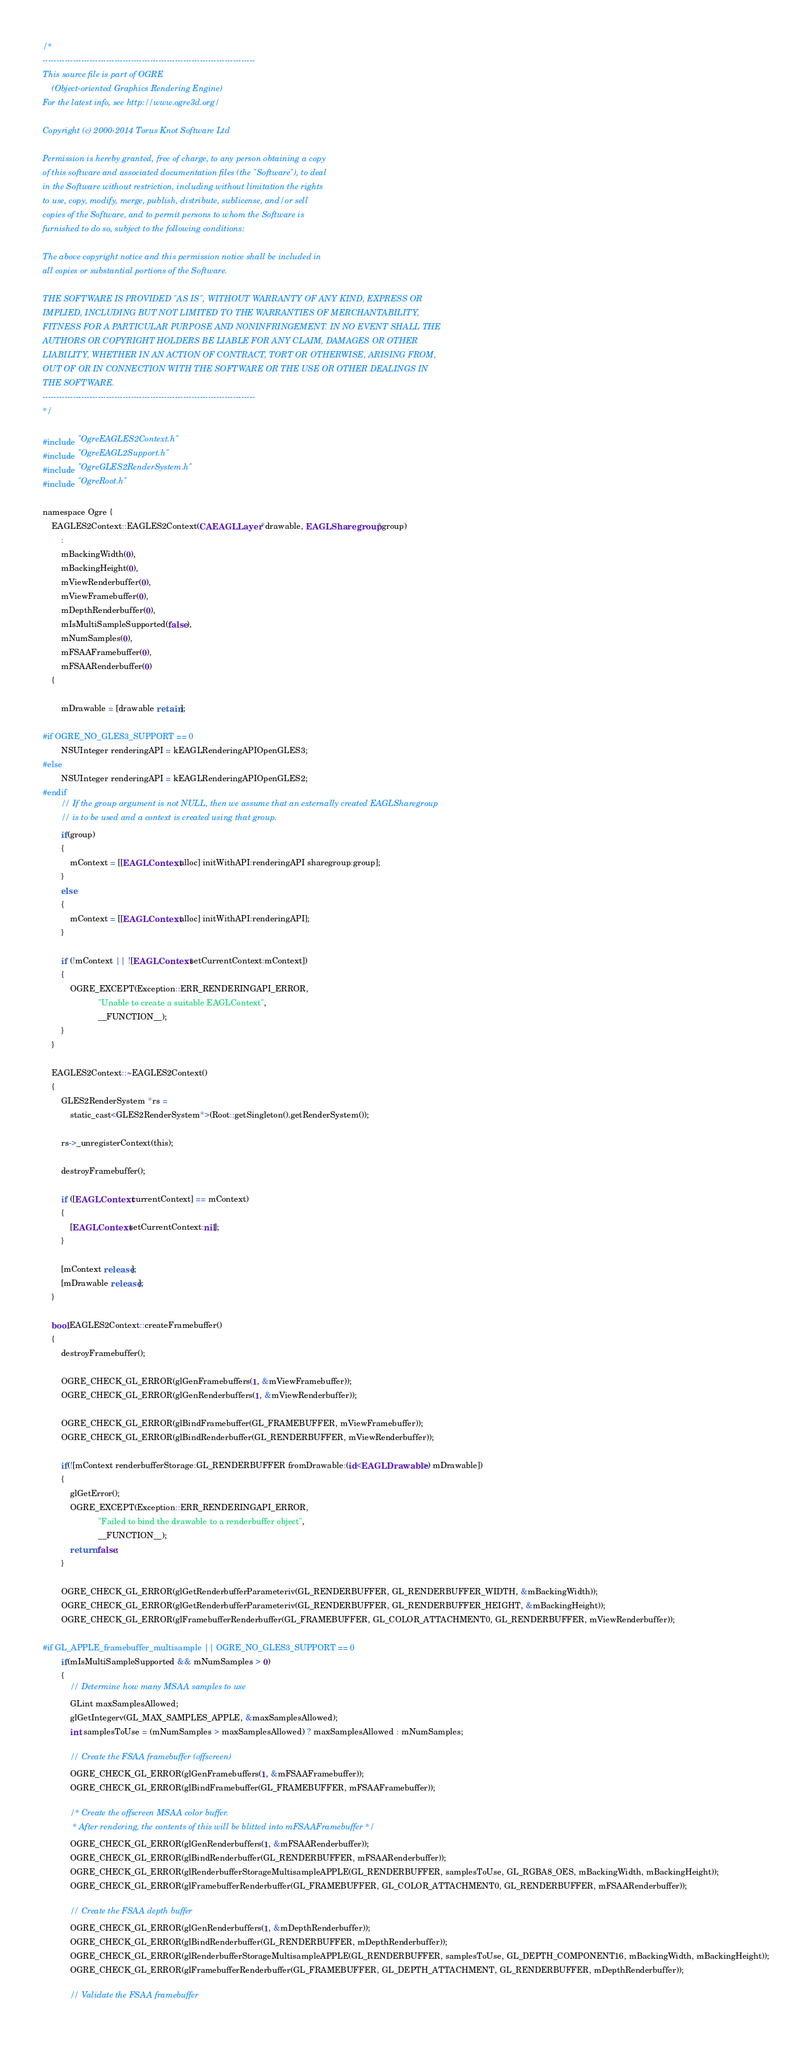<code> <loc_0><loc_0><loc_500><loc_500><_ObjectiveC_>/*
-----------------------------------------------------------------------------
This source file is part of OGRE
    (Object-oriented Graphics Rendering Engine)
For the latest info, see http://www.ogre3d.org/

Copyright (c) 2000-2014 Torus Knot Software Ltd

Permission is hereby granted, free of charge, to any person obtaining a copy
of this software and associated documentation files (the "Software"), to deal
in the Software without restriction, including without limitation the rights
to use, copy, modify, merge, publish, distribute, sublicense, and/or sell
copies of the Software, and to permit persons to whom the Software is
furnished to do so, subject to the following conditions:

The above copyright notice and this permission notice shall be included in
all copies or substantial portions of the Software.

THE SOFTWARE IS PROVIDED "AS IS", WITHOUT WARRANTY OF ANY KIND, EXPRESS OR
IMPLIED, INCLUDING BUT NOT LIMITED TO THE WARRANTIES OF MERCHANTABILITY,
FITNESS FOR A PARTICULAR PURPOSE AND NONINFRINGEMENT. IN NO EVENT SHALL THE
AUTHORS OR COPYRIGHT HOLDERS BE LIABLE FOR ANY CLAIM, DAMAGES OR OTHER
LIABILITY, WHETHER IN AN ACTION OF CONTRACT, TORT OR OTHERWISE, ARISING FROM,
OUT OF OR IN CONNECTION WITH THE SOFTWARE OR THE USE OR OTHER DEALINGS IN
THE SOFTWARE.
-----------------------------------------------------------------------------
*/

#include "OgreEAGLES2Context.h"
#include "OgreEAGL2Support.h"
#include "OgreGLES2RenderSystem.h"
#include "OgreRoot.h"

namespace Ogre {
    EAGLES2Context::EAGLES2Context(CAEAGLLayer *drawable, EAGLSharegroup *group)
        : 
        mBackingWidth(0),
        mBackingHeight(0),
        mViewRenderbuffer(0),
        mViewFramebuffer(0),
        mDepthRenderbuffer(0),
        mIsMultiSampleSupported(false),
        mNumSamples(0),
        mFSAAFramebuffer(0),
        mFSAARenderbuffer(0)
    {

        mDrawable = [drawable retain];

#if OGRE_NO_GLES3_SUPPORT == 0
        NSUInteger renderingAPI = kEAGLRenderingAPIOpenGLES3;
#else
        NSUInteger renderingAPI = kEAGLRenderingAPIOpenGLES2;
#endif
        // If the group argument is not NULL, then we assume that an externally created EAGLSharegroup
        // is to be used and a context is created using that group.
        if(group)
        {
            mContext = [[EAGLContext alloc] initWithAPI:renderingAPI sharegroup:group];
        }
        else
        {
            mContext = [[EAGLContext alloc] initWithAPI:renderingAPI];
        }

        if (!mContext || ![EAGLContext setCurrentContext:mContext])
        {
            OGRE_EXCEPT(Exception::ERR_RENDERINGAPI_ERROR,
                        "Unable to create a suitable EAGLContext",
                        __FUNCTION__);
        }
    }

    EAGLES2Context::~EAGLES2Context()
    {
        GLES2RenderSystem *rs =
            static_cast<GLES2RenderSystem*>(Root::getSingleton().getRenderSystem());

        rs->_unregisterContext(this);

        destroyFramebuffer();

        if ([EAGLContext currentContext] == mContext)
        {
            [EAGLContext setCurrentContext:nil];
        }
        
        [mContext release];
        [mDrawable release];
    }

    bool EAGLES2Context::createFramebuffer()
    {
        destroyFramebuffer();

        OGRE_CHECK_GL_ERROR(glGenFramebuffers(1, &mViewFramebuffer));
        OGRE_CHECK_GL_ERROR(glGenRenderbuffers(1, &mViewRenderbuffer));
        
        OGRE_CHECK_GL_ERROR(glBindFramebuffer(GL_FRAMEBUFFER, mViewFramebuffer));
        OGRE_CHECK_GL_ERROR(glBindRenderbuffer(GL_RENDERBUFFER, mViewRenderbuffer));

        if(![mContext renderbufferStorage:GL_RENDERBUFFER fromDrawable:(id<EAGLDrawable>) mDrawable])
        {
            glGetError();
            OGRE_EXCEPT(Exception::ERR_RENDERINGAPI_ERROR,
                        "Failed to bind the drawable to a renderbuffer object",
                        __FUNCTION__);
            return false;
        }

        OGRE_CHECK_GL_ERROR(glGetRenderbufferParameteriv(GL_RENDERBUFFER, GL_RENDERBUFFER_WIDTH, &mBackingWidth));
        OGRE_CHECK_GL_ERROR(glGetRenderbufferParameteriv(GL_RENDERBUFFER, GL_RENDERBUFFER_HEIGHT, &mBackingHeight));
        OGRE_CHECK_GL_ERROR(glFramebufferRenderbuffer(GL_FRAMEBUFFER, GL_COLOR_ATTACHMENT0, GL_RENDERBUFFER, mViewRenderbuffer));

#if GL_APPLE_framebuffer_multisample || OGRE_NO_GLES3_SUPPORT == 0
        if(mIsMultiSampleSupported && mNumSamples > 0)
        {
            // Determine how many MSAA samples to use
            GLint maxSamplesAllowed;
            glGetIntegerv(GL_MAX_SAMPLES_APPLE, &maxSamplesAllowed);
            int samplesToUse = (mNumSamples > maxSamplesAllowed) ? maxSamplesAllowed : mNumSamples;
            
            // Create the FSAA framebuffer (offscreen)
            OGRE_CHECK_GL_ERROR(glGenFramebuffers(1, &mFSAAFramebuffer));
            OGRE_CHECK_GL_ERROR(glBindFramebuffer(GL_FRAMEBUFFER, mFSAAFramebuffer));

            /* Create the offscreen MSAA color buffer.
             * After rendering, the contents of this will be blitted into mFSAAFramebuffer */
            OGRE_CHECK_GL_ERROR(glGenRenderbuffers(1, &mFSAARenderbuffer));
            OGRE_CHECK_GL_ERROR(glBindRenderbuffer(GL_RENDERBUFFER, mFSAARenderbuffer));
            OGRE_CHECK_GL_ERROR(glRenderbufferStorageMultisampleAPPLE(GL_RENDERBUFFER, samplesToUse, GL_RGBA8_OES, mBackingWidth, mBackingHeight));
            OGRE_CHECK_GL_ERROR(glFramebufferRenderbuffer(GL_FRAMEBUFFER, GL_COLOR_ATTACHMENT0, GL_RENDERBUFFER, mFSAARenderbuffer));

            // Create the FSAA depth buffer
            OGRE_CHECK_GL_ERROR(glGenRenderbuffers(1, &mDepthRenderbuffer));
            OGRE_CHECK_GL_ERROR(glBindRenderbuffer(GL_RENDERBUFFER, mDepthRenderbuffer));
            OGRE_CHECK_GL_ERROR(glRenderbufferStorageMultisampleAPPLE(GL_RENDERBUFFER, samplesToUse, GL_DEPTH_COMPONENT16, mBackingWidth, mBackingHeight));
            OGRE_CHECK_GL_ERROR(glFramebufferRenderbuffer(GL_FRAMEBUFFER, GL_DEPTH_ATTACHMENT, GL_RENDERBUFFER, mDepthRenderbuffer));

            // Validate the FSAA framebuffer</code> 